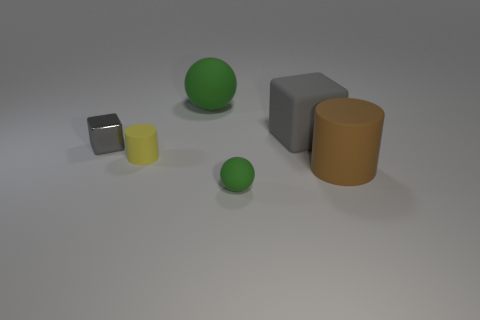Is the number of gray shiny cubes less than the number of red shiny cylinders?
Provide a short and direct response. No. Are the tiny green thing and the big sphere made of the same material?
Keep it short and to the point. Yes. What number of other things are the same size as the brown matte cylinder?
Provide a short and direct response. 2. There is a ball that is behind the green sphere that is in front of the metallic block; what color is it?
Offer a terse response. Green. What number of other objects are there of the same shape as the small gray object?
Your answer should be very brief. 1. Are there any other large cyan cubes made of the same material as the big block?
Your answer should be very brief. No. There is a cube that is the same size as the yellow rubber object; what material is it?
Your answer should be compact. Metal. What is the color of the small object on the right side of the rubber sphere left of the green matte ball in front of the small block?
Make the answer very short. Green. There is a object that is in front of the brown matte object; is it the same shape as the large thing that is in front of the metallic object?
Your answer should be compact. No. What number of rubber balls are there?
Your answer should be compact. 2. 